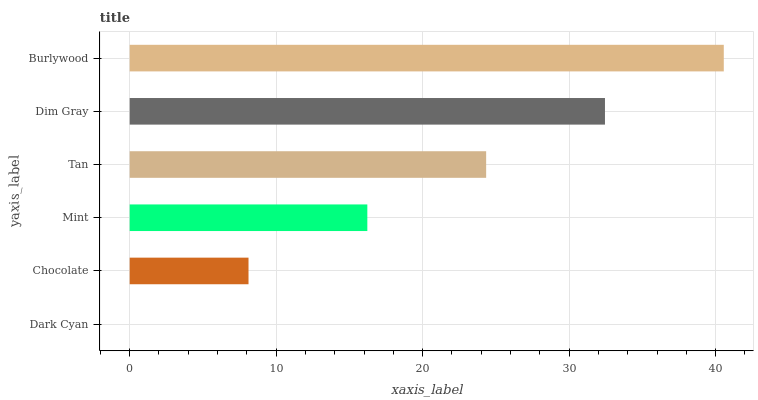Is Dark Cyan the minimum?
Answer yes or no. Yes. Is Burlywood the maximum?
Answer yes or no. Yes. Is Chocolate the minimum?
Answer yes or no. No. Is Chocolate the maximum?
Answer yes or no. No. Is Chocolate greater than Dark Cyan?
Answer yes or no. Yes. Is Dark Cyan less than Chocolate?
Answer yes or no. Yes. Is Dark Cyan greater than Chocolate?
Answer yes or no. No. Is Chocolate less than Dark Cyan?
Answer yes or no. No. Is Tan the high median?
Answer yes or no. Yes. Is Mint the low median?
Answer yes or no. Yes. Is Dim Gray the high median?
Answer yes or no. No. Is Chocolate the low median?
Answer yes or no. No. 